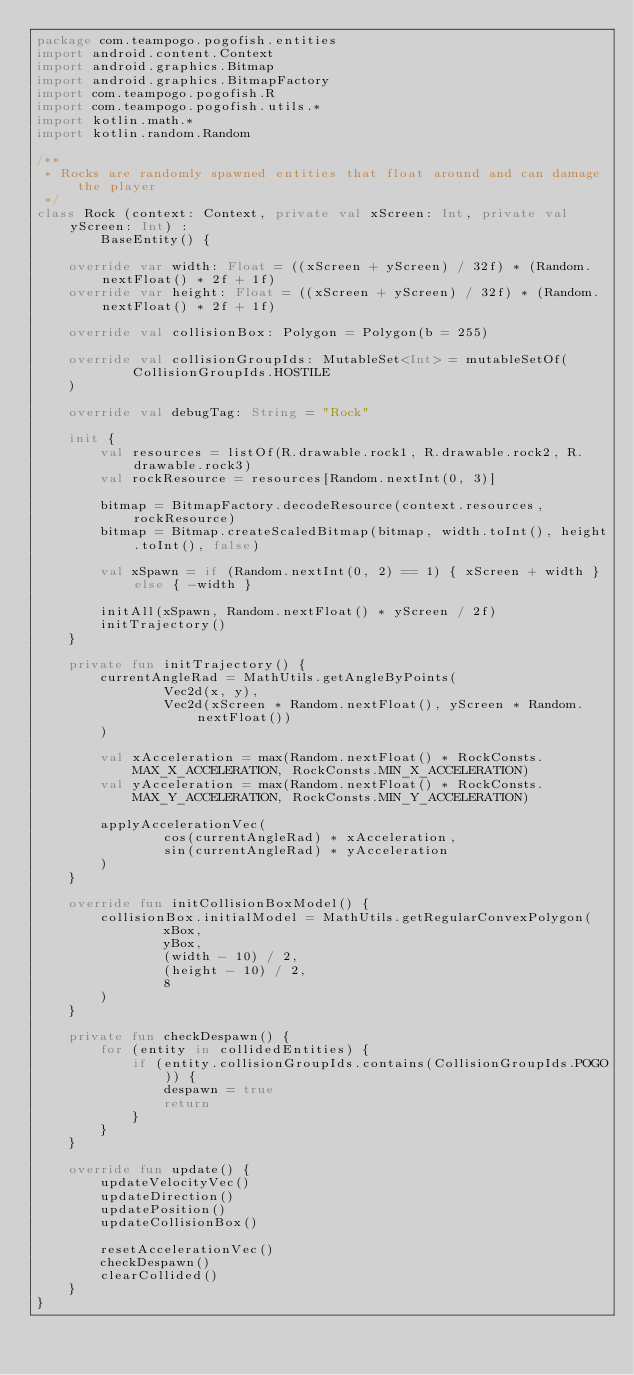Convert code to text. <code><loc_0><loc_0><loc_500><loc_500><_Kotlin_>package com.teampogo.pogofish.entities
import android.content.Context
import android.graphics.Bitmap
import android.graphics.BitmapFactory
import com.teampogo.pogofish.R
import com.teampogo.pogofish.utils.*
import kotlin.math.*
import kotlin.random.Random

/**
 * Rocks are randomly spawned entities that float around and can damage the player
 */
class Rock (context: Context, private val xScreen: Int, private val yScreen: Int) :
        BaseEntity() {

    override var width: Float = ((xScreen + yScreen) / 32f) * (Random.nextFloat() * 2f + 1f)
    override var height: Float = ((xScreen + yScreen) / 32f) * (Random.nextFloat() * 2f + 1f)

    override val collisionBox: Polygon = Polygon(b = 255)

    override val collisionGroupIds: MutableSet<Int> = mutableSetOf(
            CollisionGroupIds.HOSTILE
    )

    override val debugTag: String = "Rock"

    init {
        val resources = listOf(R.drawable.rock1, R.drawable.rock2, R.drawable.rock3)
        val rockResource = resources[Random.nextInt(0, 3)]

        bitmap = BitmapFactory.decodeResource(context.resources, rockResource)
        bitmap = Bitmap.createScaledBitmap(bitmap, width.toInt(), height.toInt(), false)

        val xSpawn = if (Random.nextInt(0, 2) == 1) { xScreen + width } else { -width }

        initAll(xSpawn, Random.nextFloat() * yScreen / 2f)
        initTrajectory()
    }

    private fun initTrajectory() {
        currentAngleRad = MathUtils.getAngleByPoints(
                Vec2d(x, y),
                Vec2d(xScreen * Random.nextFloat(), yScreen * Random.nextFloat())
        )

        val xAcceleration = max(Random.nextFloat() * RockConsts.MAX_X_ACCELERATION, RockConsts.MIN_X_ACCELERATION)
        val yAcceleration = max(Random.nextFloat() * RockConsts.MAX_Y_ACCELERATION, RockConsts.MIN_Y_ACCELERATION)

        applyAccelerationVec(
                cos(currentAngleRad) * xAcceleration,
                sin(currentAngleRad) * yAcceleration
        )
    }

    override fun initCollisionBoxModel() {
        collisionBox.initialModel = MathUtils.getRegularConvexPolygon(
                xBox,
                yBox,
                (width - 10) / 2,
                (height - 10) / 2,
                8
        )
    }

    private fun checkDespawn() {
        for (entity in collidedEntities) {
            if (entity.collisionGroupIds.contains(CollisionGroupIds.POGO)) {
                despawn = true
                return
            }
        }
    }

    override fun update() {
        updateVelocityVec()
        updateDirection()
        updatePosition()
        updateCollisionBox()

        resetAccelerationVec()
        checkDespawn()
        clearCollided()
    }
}</code> 